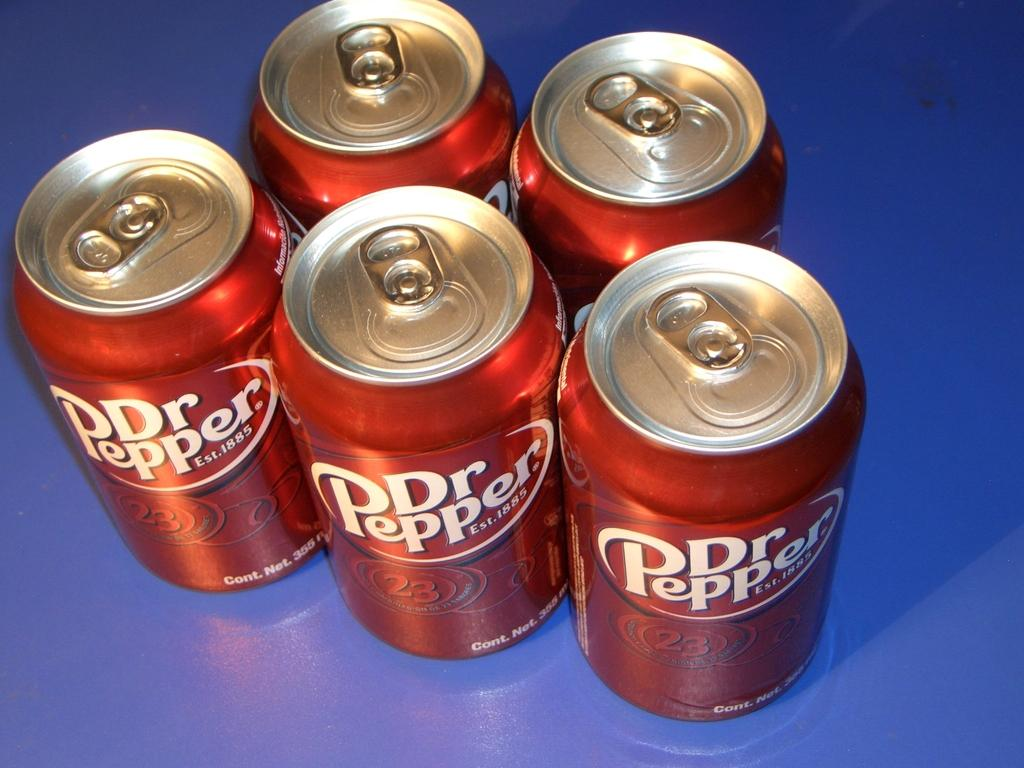<image>
Summarize the visual content of the image. Five Dr. Pepper cans are displayed on a counter. 